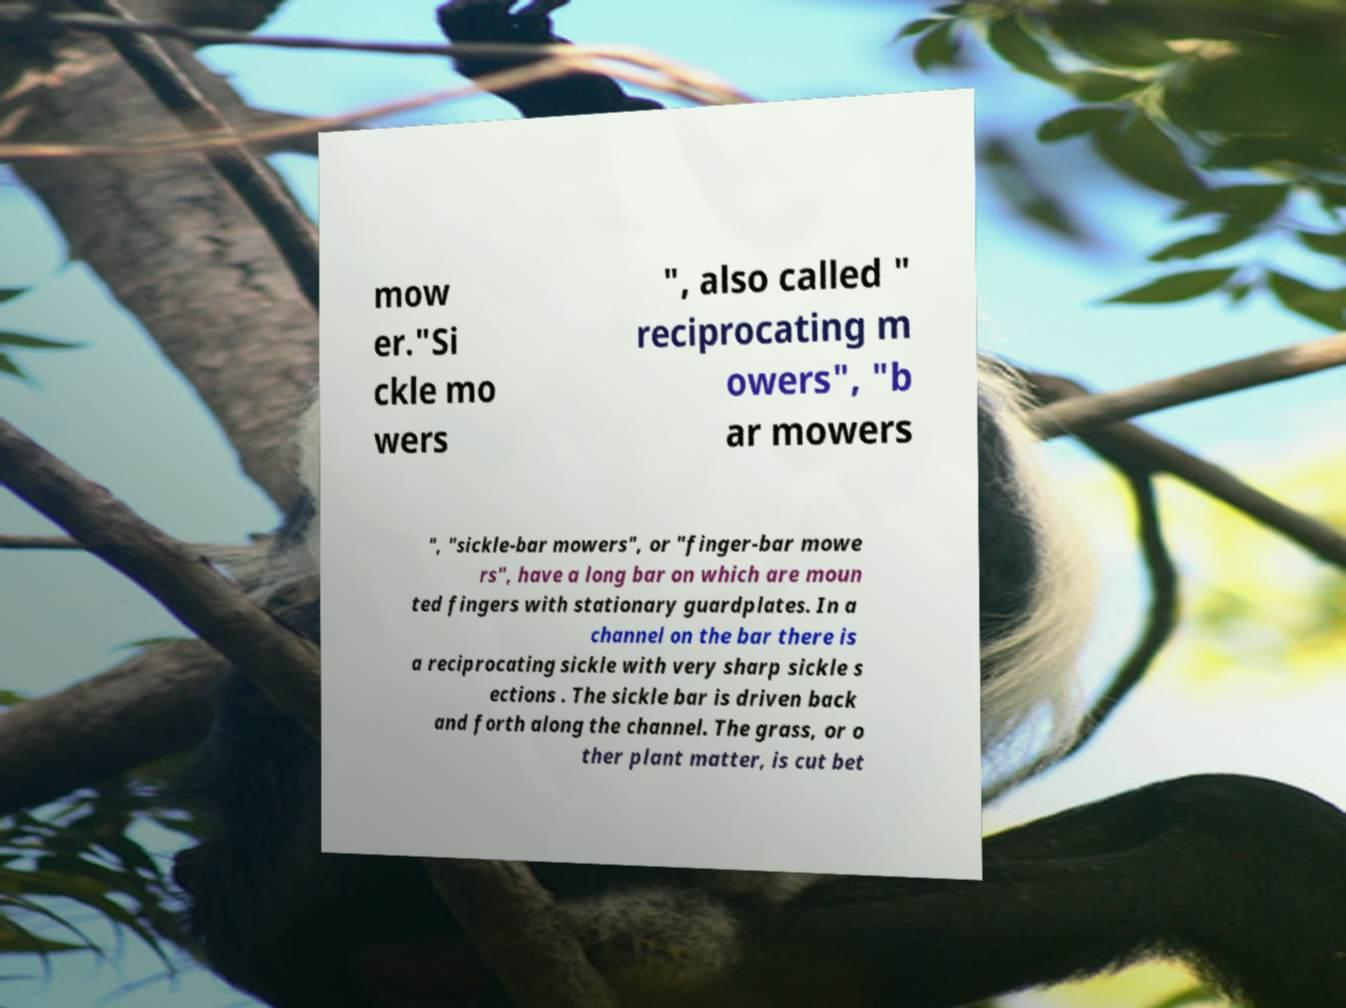Please read and relay the text visible in this image. What does it say? mow er."Si ckle mo wers ", also called " reciprocating m owers", "b ar mowers ", "sickle-bar mowers", or "finger-bar mowe rs", have a long bar on which are moun ted fingers with stationary guardplates. In a channel on the bar there is a reciprocating sickle with very sharp sickle s ections . The sickle bar is driven back and forth along the channel. The grass, or o ther plant matter, is cut bet 